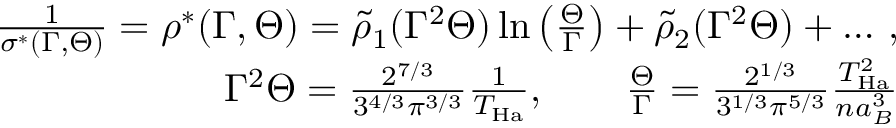Convert formula to latex. <formula><loc_0><loc_0><loc_500><loc_500>\begin{array} { r l r } & { \frac { 1 } { \sigma ^ { * } ( \Gamma , \Theta ) } = \rho ^ { * } ( \Gamma , \Theta ) = \tilde { \rho } _ { 1 } ( \Gamma ^ { 2 } \Theta ) \ln \left ( \frac { \Theta } { \Gamma } \right ) + \tilde { \rho } _ { 2 } ( \Gamma ^ { 2 } \Theta ) + \dots \, , } \\ & { \Gamma ^ { 2 } \Theta = \frac { 2 ^ { 7 / 3 } } { 3 ^ { 4 / 3 } \pi ^ { 3 / 3 } } \frac { 1 } { T _ { H a } } , \quad \frac { \Theta } { \Gamma } = \frac { 2 ^ { 1 / 3 } } { 3 ^ { 1 / 3 } \pi ^ { 5 / 3 } } \frac { T _ { H a } ^ { 2 } } { n a _ { B } ^ { 3 } } } \end{array}</formula> 